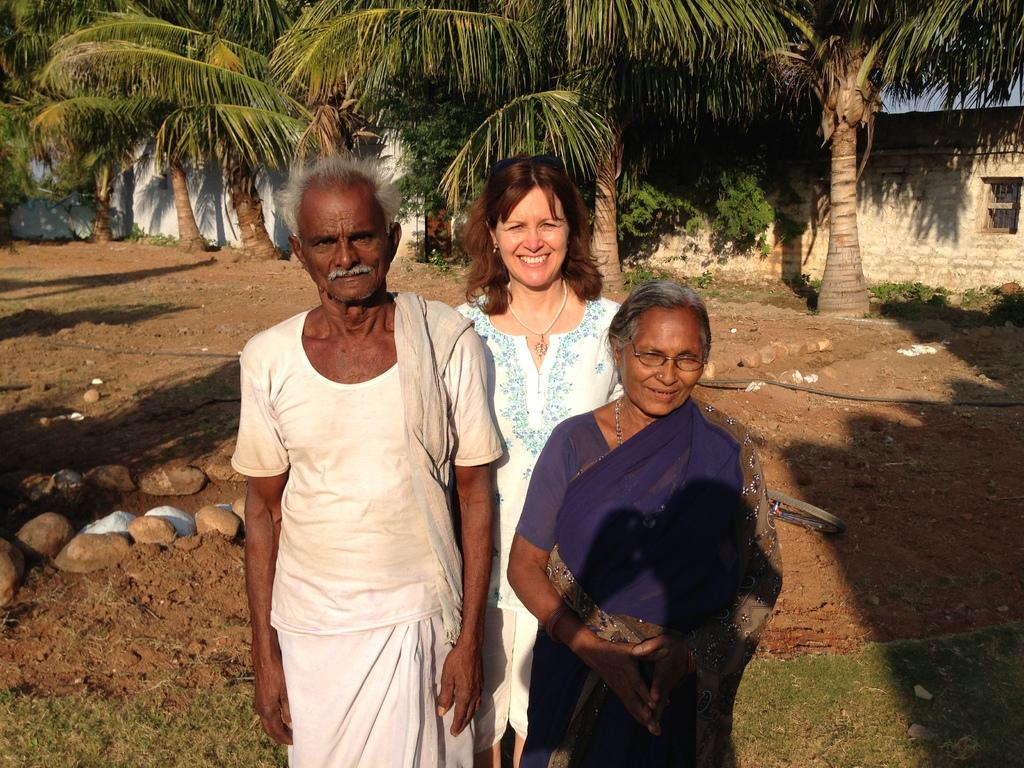How many people are present in the image? There are three persons standing in the image. What type of natural elements can be seen in the image? There are rocks, plants, grass, and trees visible in the image. What is the background of the image composed of? There are walls visible in the background of the image. What type of hen can be seen in the image? There is no hen present in the image. What type of tools does the carpenter have in the image? There is no carpenter or tools present in the image. 